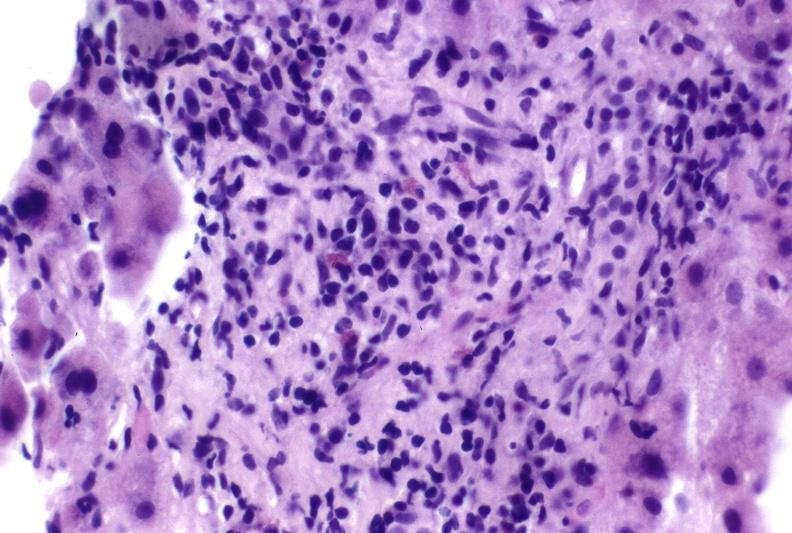what is present?
Answer the question using a single word or phrase. Hepatobiliary 